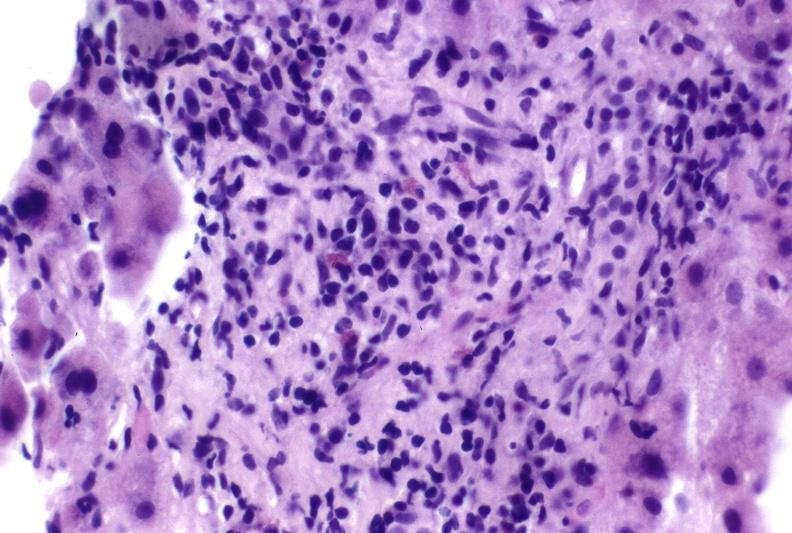what is present?
Answer the question using a single word or phrase. Hepatobiliary 